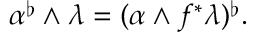<formula> <loc_0><loc_0><loc_500><loc_500>\alpha ^ { \flat } \wedge \lambda = ( \alpha \wedge f ^ { * } \lambda ) ^ { \flat } .</formula> 